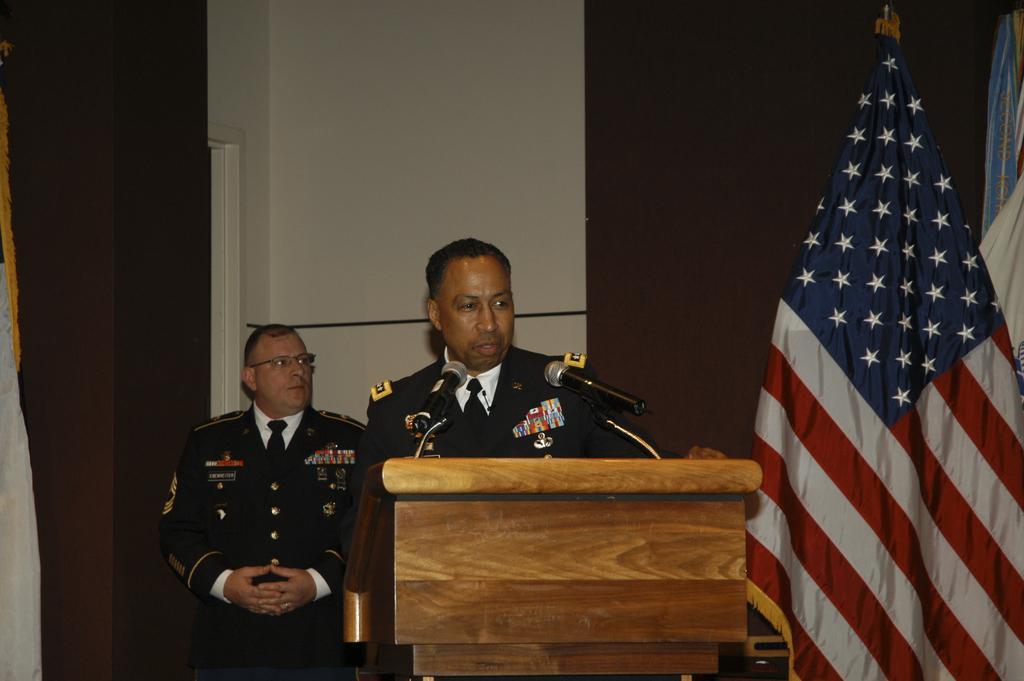In one or two sentences, can you explain what this image depicts? In this image, we can see two people wearing uniform and one of them is wearing glasses. In the background, we can see a flag and there are some clothes and a curtain and there is a wall. In the front, there is a podium and a mic. 